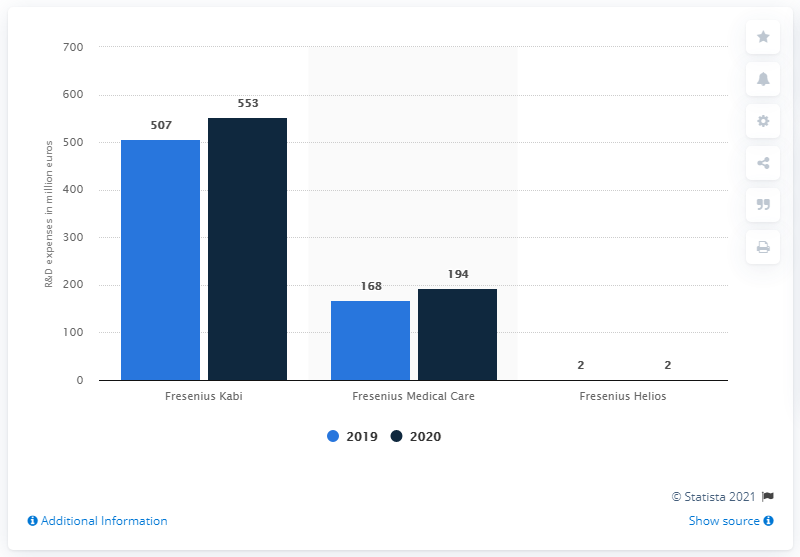Mention a couple of crucial points in this snapshot. Fresenius SE's Fresenius Kabi segment spent 553 on research and development in 2020. 